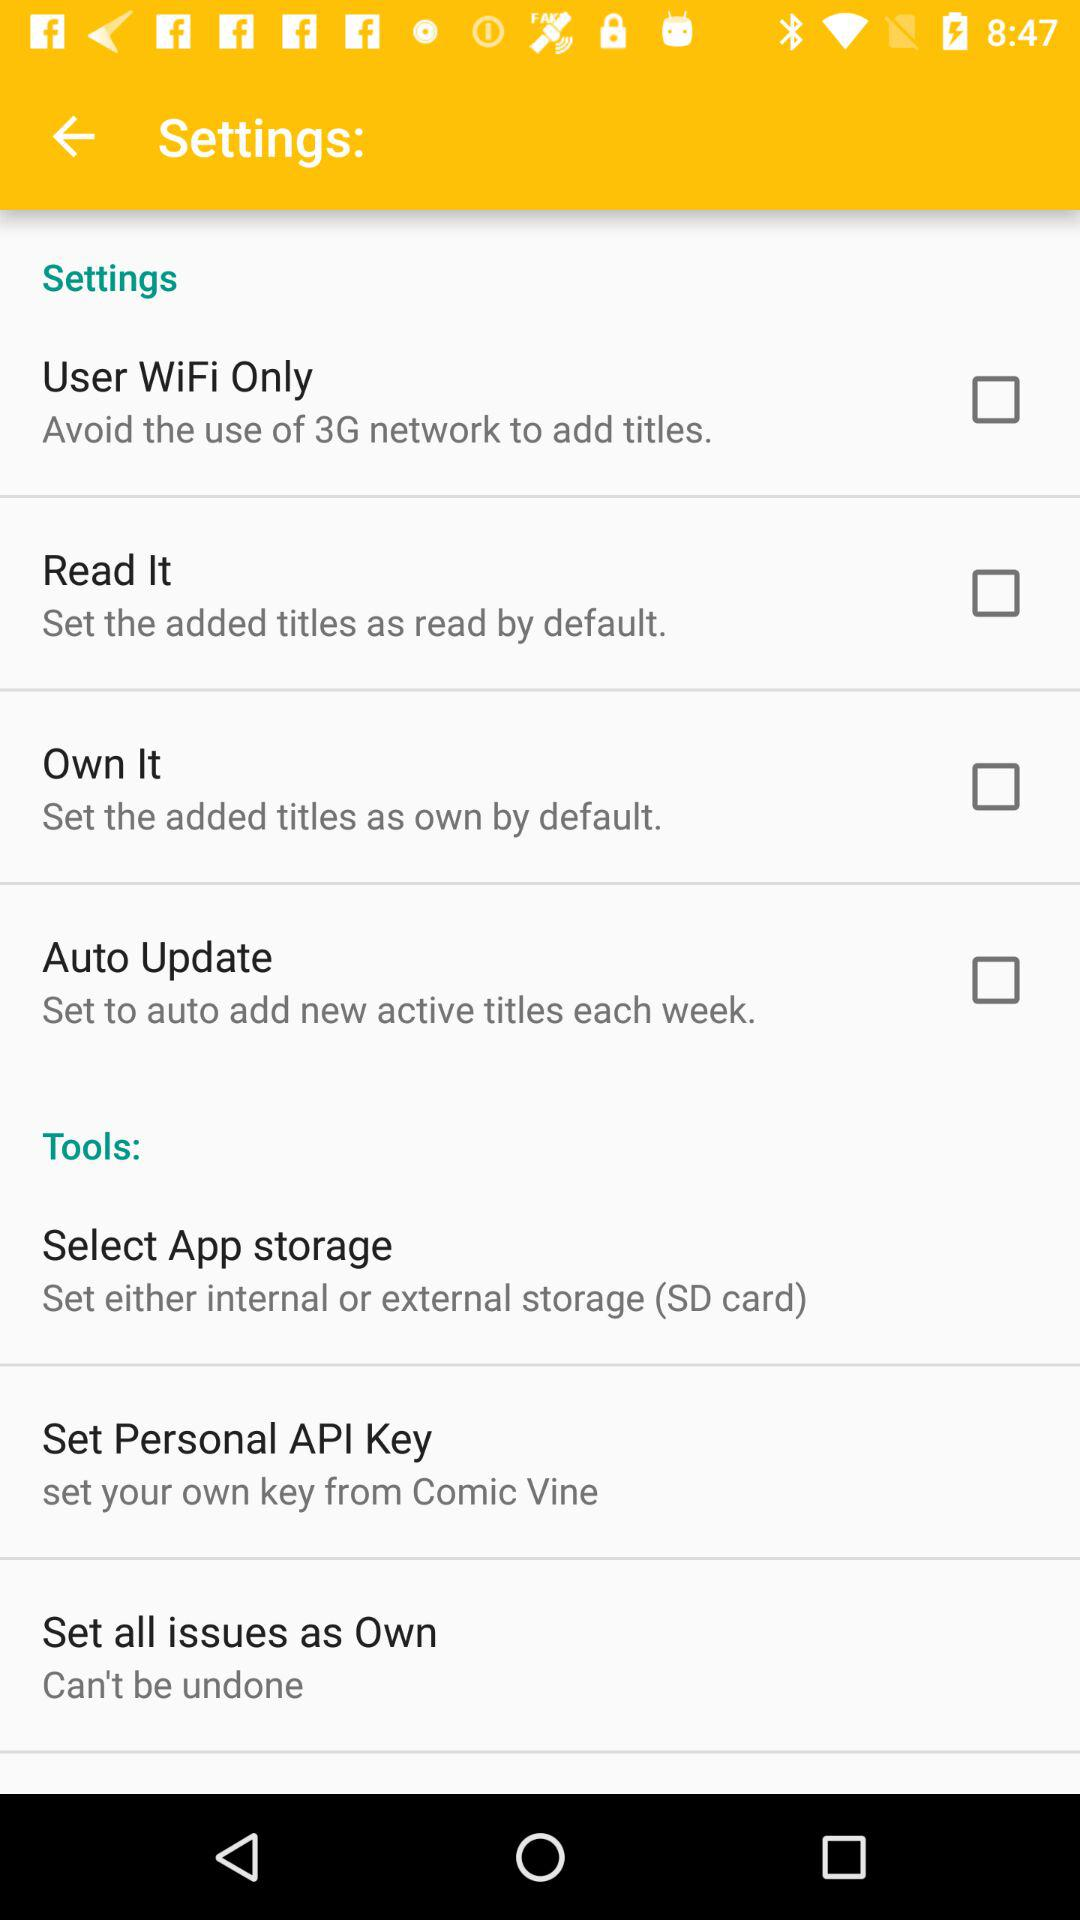What is the status of "User WiFi Only"? The status is "off". 